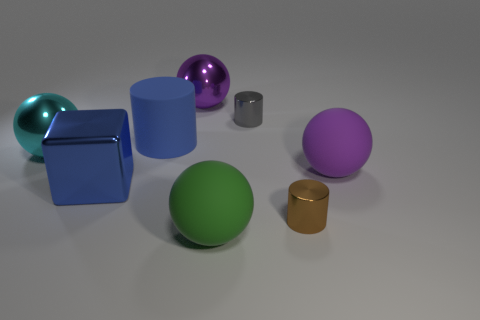How many cubes are either big cyan metal objects or blue things?
Offer a terse response. 1. There is a big metal thing that is in front of the big purple matte sphere; is its color the same as the big rubber cylinder?
Your answer should be compact. Yes. What material is the big ball that is in front of the matte object on the right side of the large green thing that is right of the cyan metallic sphere?
Give a very brief answer. Rubber. Is the metal block the same size as the brown thing?
Your answer should be very brief. No. Does the matte cylinder have the same color as the cube on the left side of the large green object?
Provide a short and direct response. Yes. There is a large cyan thing that is the same material as the large blue block; what is its shape?
Give a very brief answer. Sphere. Do the big blue object that is in front of the large cyan ball and the large purple matte thing have the same shape?
Keep it short and to the point. No. What is the size of the matte object that is in front of the large matte ball behind the big blue metallic object?
Your answer should be compact. Large. There is a cube that is the same material as the big cyan object; what is its color?
Provide a succinct answer. Blue. How many green matte things are the same size as the brown cylinder?
Ensure brevity in your answer.  0. 